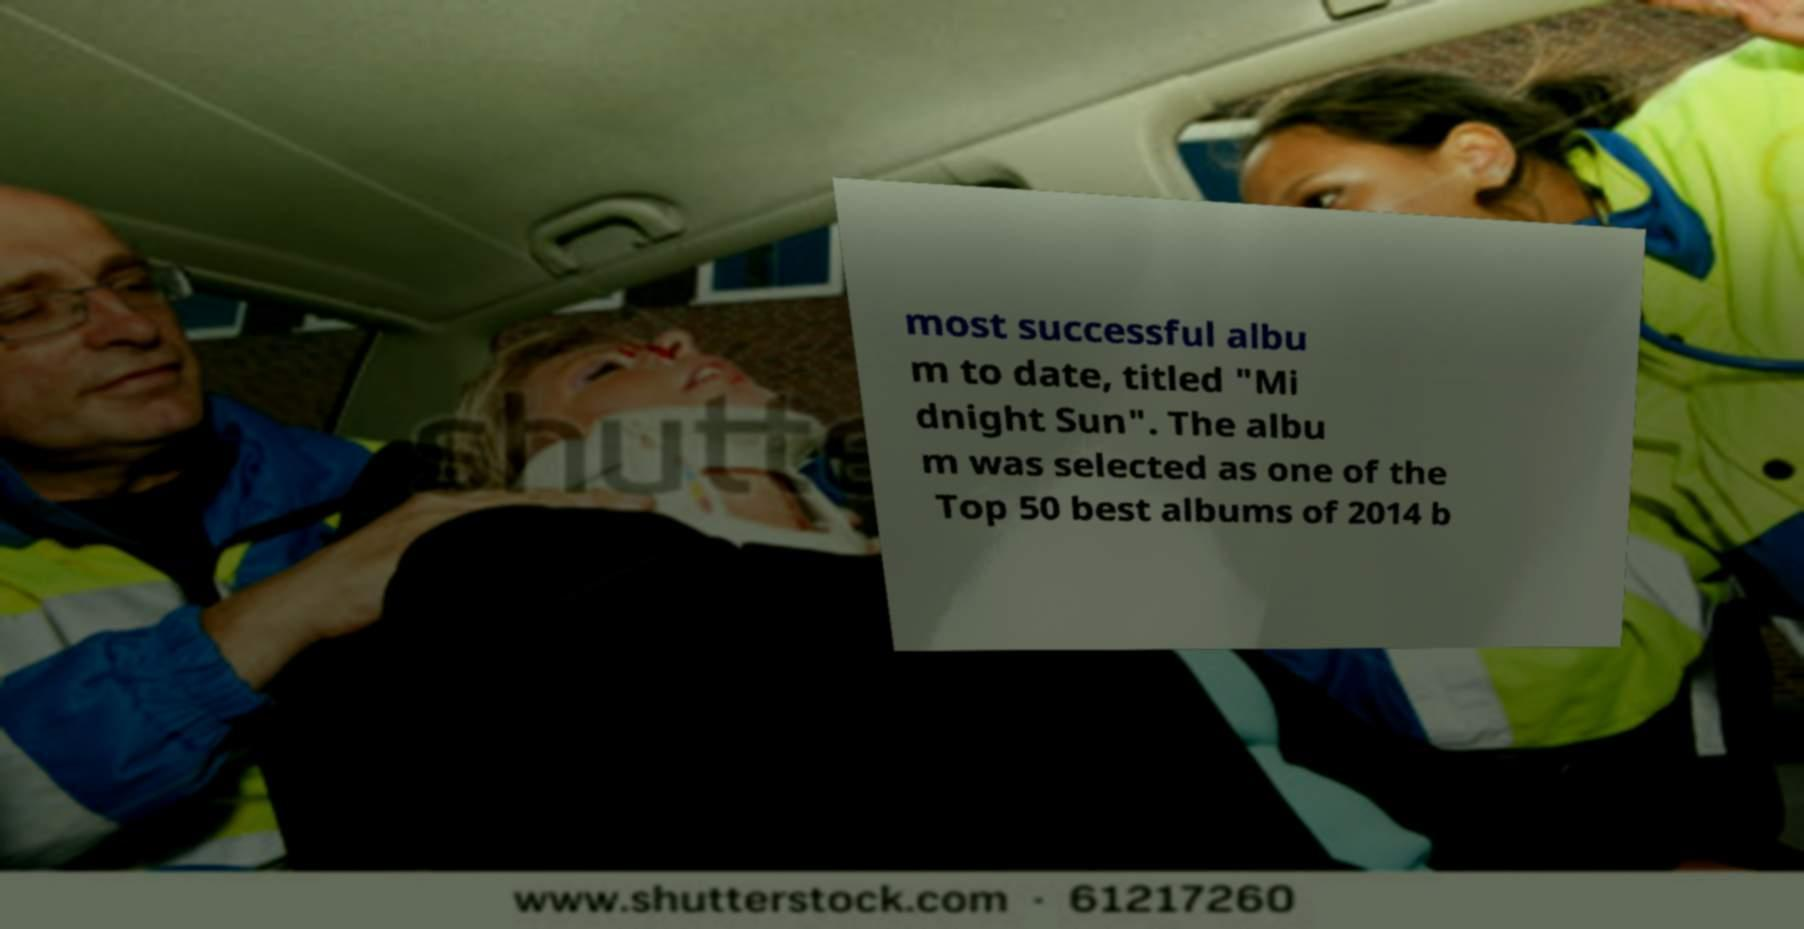There's text embedded in this image that I need extracted. Can you transcribe it verbatim? most successful albu m to date, titled "Mi dnight Sun". The albu m was selected as one of the Top 50 best albums of 2014 b 